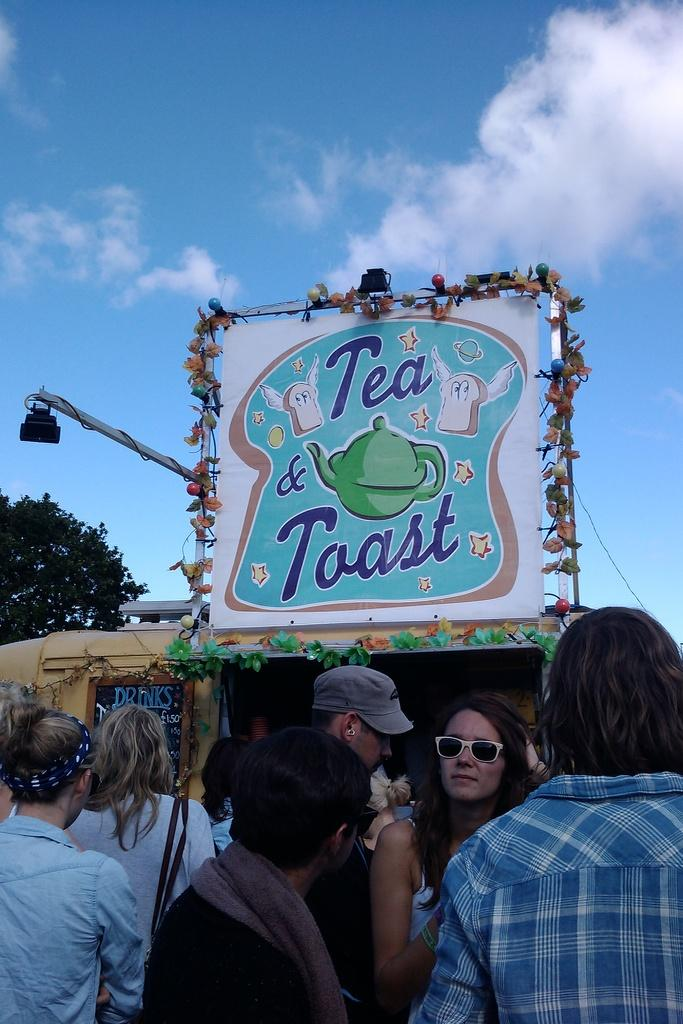What can be seen at the bottom of the image? There are people at the bottom of the image. What is located in the middle of the image? There is a board in the middle of the image. What type of vegetation is on the left side of the image? There is a tree on the left side of the image. What is visible at the top of the image? The sky is visible at the top of the image. What type of building is depicted in the image? There is no building present in the image. What emotion is being expressed by the tree in the image? Trees do not express emotions, so this question cannot be answered. 